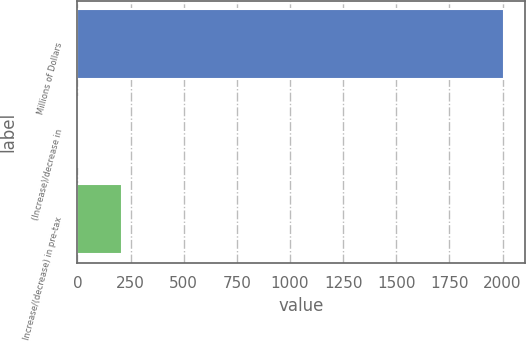Convert chart to OTSL. <chart><loc_0><loc_0><loc_500><loc_500><bar_chart><fcel>Millions of Dollars<fcel>(Increase)/decrease in<fcel>Increase/(decrease) in pre-tax<nl><fcel>2007<fcel>8<fcel>207.9<nl></chart> 